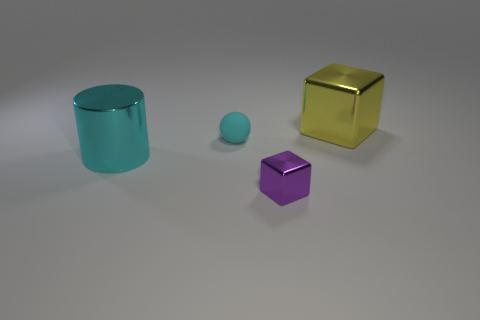Add 2 cyan balls. How many objects exist? 6 Subtract all spheres. How many objects are left? 3 Subtract all yellow blocks. How many blocks are left? 1 Add 2 big cyan metal things. How many big cyan metal things are left? 3 Add 3 large yellow cubes. How many large yellow cubes exist? 4 Subtract 1 cyan balls. How many objects are left? 3 Subtract 1 blocks. How many blocks are left? 1 Subtract all red balls. Subtract all yellow blocks. How many balls are left? 1 Subtract all big cyan things. Subtract all large things. How many objects are left? 1 